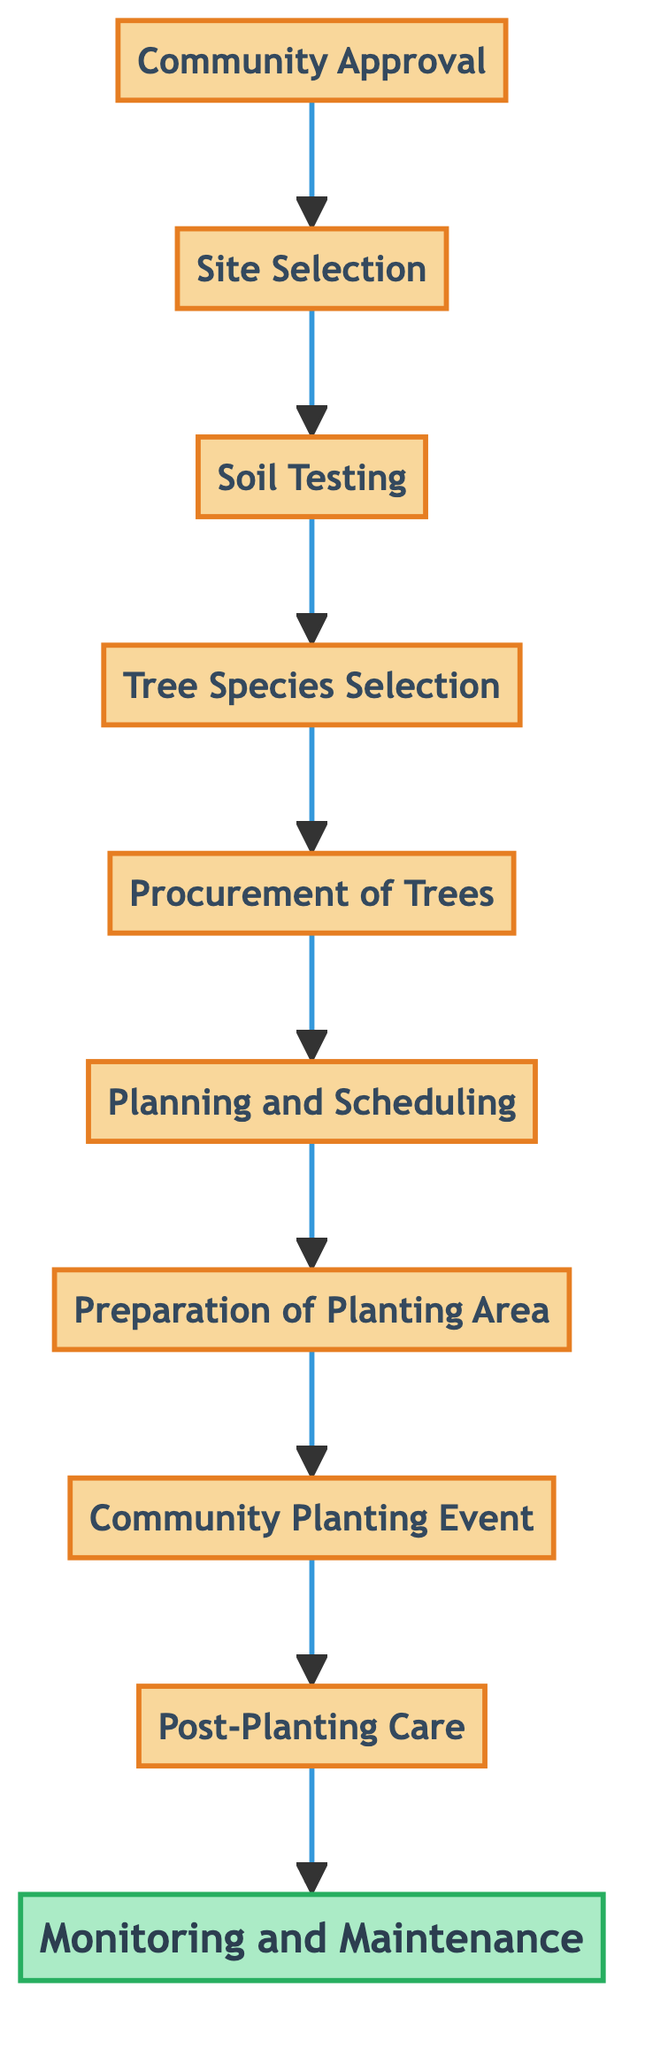What is the first step in the tree planting process? The first step is indicated at the bottom of the flowchart, which is "Community Approval." This is the starting point of the process before any planting activities occur.
Answer: Community Approval How many nodes are present in the diagram? By counting each distinct block or step in the flowchart, there are a total of ten nodes that represent the various stages in the tree planting process.
Answer: Ten What is the last step after the Community Planting Event? The last step in the flowchart follows the "Community Planting Event" and is represented by "Post-Planting Care," emphasizing the necessity of care for the newly planted trees.
Answer: Post-Planting Care What comes after Soil Testing? Analyzing the flow from "Soil Testing," the next step that follows is "Tree Species Selection," indicating the process of selecting appropriate trees based on the test results.
Answer: Tree Species Selection Which step involves preparing the site for planting? The step focusing on the preparation of the planting area is "Preparation of Planting Area," which includes clearing debris and digging holes. This step is critical to ensure a proper environment for the trees.
Answer: Preparation of Planting Area What is the relationship between the Site Selection and Soil Testing? The relationship between "Site Selection" and "Soil Testing" indicates that soil tests can only occur after suitable sites have been chosen, as the testing is dependent on the selected locations. This implies a sequential flow of actions from one to the other.
Answer: Sequential dependence Which step focuses on working with the community? The "Community Planting Event" is the step that places significant emphasis on community involvement, as it gathers residents of Buramai together to participate actively in the planting process.
Answer: Community Planting Event What type of care is highlighted after planting? The flowchart highlights "Post-Planting Care" as the specific type of care emphasized after planting the trees, which includes activities like watering and mulching.
Answer: Post-Planting Care Identify the number of steps from Site Selection to Monitoring and Maintenance. Counting the steps from "Site Selection" to "Monitoring and Maintenance" includes: Site Selection, Soil Testing, Tree Species Selection, Procurement of Trees, Planning and Scheduling, Preparation of Planting Area, Community Planting Event, Post-Planting Care, and Monitoring and Maintenance, which totals to eight steps.
Answer: Eight 